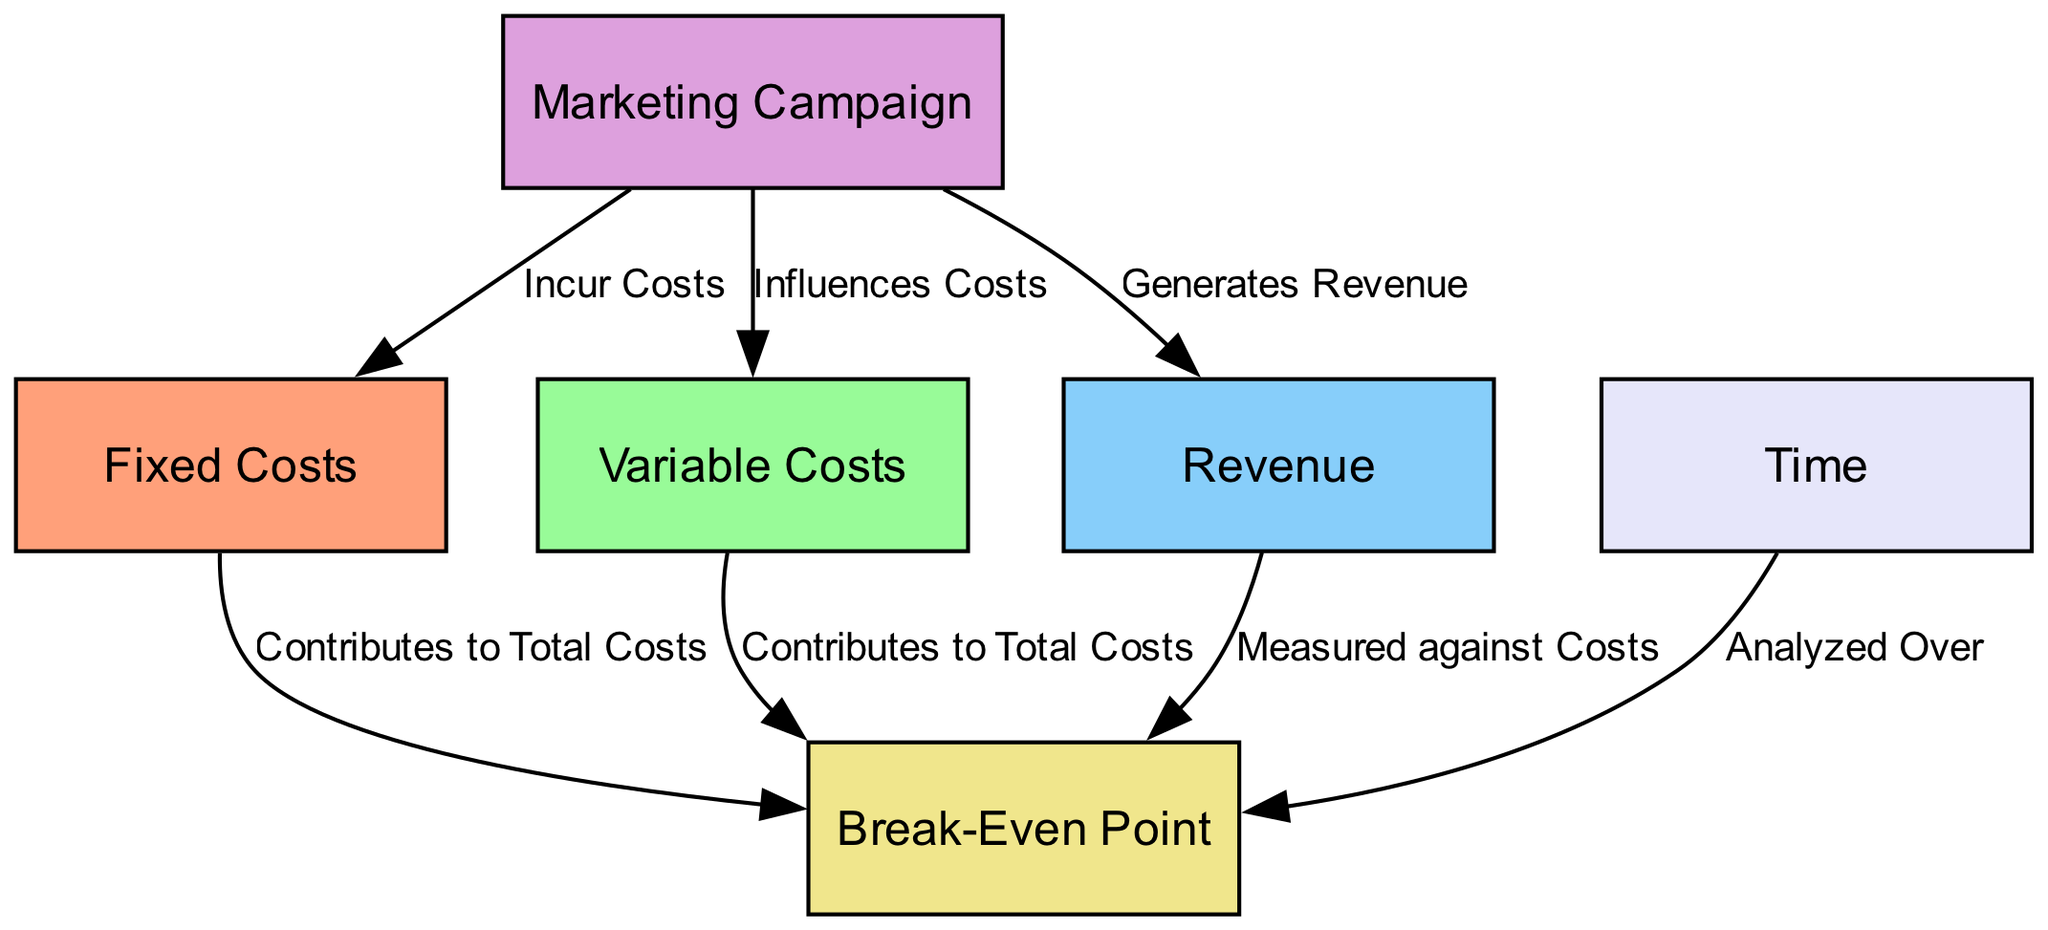What are fixed costs? Fixed costs are defined as costs that remain constant regardless of sales volume, visualized as a node labeled "Fixed Costs" in the diagram.
Answer: Costs that remain constant regardless of sales volume How many nodes are in the diagram? The diagram contains six nodes, each representing a different aspect of the break-even analysis: fixed costs, variable costs, revenue, marketing campaign, break-even point, and time.
Answer: Six What is the relationship between the marketing campaign and revenue? The arrow connecting the "Marketing Campaign" node to the "Revenue" node is labeled "Generates Revenue," indicating that the marketing campaign leads to the generation of revenue.
Answer: Generates Revenue What two types of costs contribute to the break-even point? The diagram indicates that both fixed costs and variable costs contribute to total costs, which are analyzed to identify the break-even point.
Answer: Fixed Costs and Variable Costs What is the break-even point? The break-even point is the specific point at which total revenue equals total costs, as detailed within the "Break-Even Point" node in the diagram.
Answer: The point where total revenue equals total costs How do variable costs affect the break-even point? Variable costs contribute to total costs, which is crucial for determining the break-even point; as variable costs change, the break-even point may also shift accordingly.
Answer: Contributes to Total Costs What aspect is analyzed over time regarding the break-even point? The time aspect, represented by the "Time" node, is closely linked to the break-even point as it demonstrates the duration over which costs and revenues are measured in the analysis.
Answer: Duration over which costs and revenues are measured Which nodes specifically indicate forms of costs? The nodes that specifically indicate forms of costs are "Fixed Costs" and "Variable Costs," both of which are defined distinctly in the diagram.
Answer: Fixed Costs and Variable Costs How does the marketing campaign influence costs? The arrow from the "Marketing Campaign" node to the "Variable Costs" node labeled "Influences Costs" shows that the marketing campaign affects the variable costs incurred by the company.
Answer: Influences Costs 